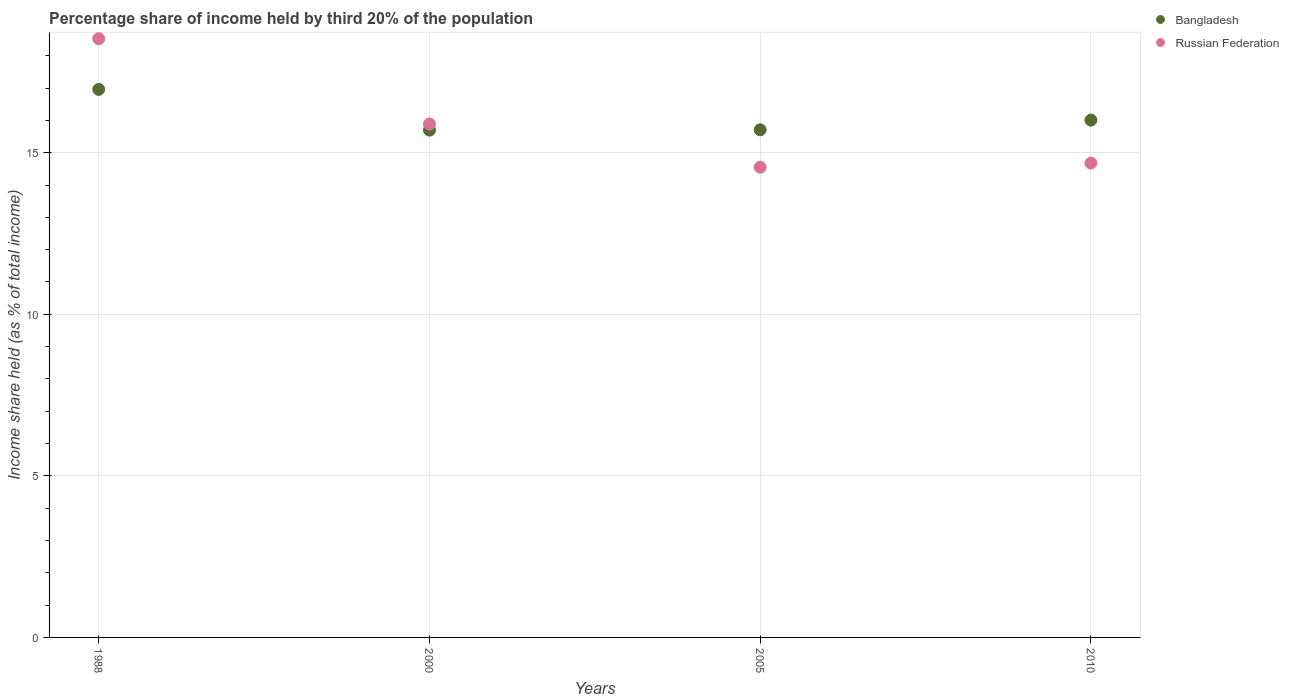What is the share of income held by third 20% of the population in Bangladesh in 2000?
Your answer should be compact. 15.7. Across all years, what is the maximum share of income held by third 20% of the population in Russian Federation?
Your answer should be compact. 18.53. In which year was the share of income held by third 20% of the population in Russian Federation maximum?
Your response must be concise. 1988. In which year was the share of income held by third 20% of the population in Russian Federation minimum?
Offer a terse response. 2005. What is the total share of income held by third 20% of the population in Bangladesh in the graph?
Offer a terse response. 64.38. What is the difference between the share of income held by third 20% of the population in Bangladesh in 2000 and that in 2005?
Offer a very short reply. -0.01. What is the difference between the share of income held by third 20% of the population in Bangladesh in 1988 and the share of income held by third 20% of the population in Russian Federation in 2005?
Provide a succinct answer. 2.41. What is the average share of income held by third 20% of the population in Bangladesh per year?
Offer a terse response. 16.09. In the year 1988, what is the difference between the share of income held by third 20% of the population in Bangladesh and share of income held by third 20% of the population in Russian Federation?
Offer a very short reply. -1.57. In how many years, is the share of income held by third 20% of the population in Russian Federation greater than 16 %?
Provide a short and direct response. 1. What is the ratio of the share of income held by third 20% of the population in Bangladesh in 2000 to that in 2005?
Provide a succinct answer. 1. What is the difference between the highest and the second highest share of income held by third 20% of the population in Russian Federation?
Your response must be concise. 2.64. What is the difference between the highest and the lowest share of income held by third 20% of the population in Russian Federation?
Your answer should be very brief. 3.98. Is the sum of the share of income held by third 20% of the population in Russian Federation in 1988 and 2005 greater than the maximum share of income held by third 20% of the population in Bangladesh across all years?
Your answer should be very brief. Yes. Does the share of income held by third 20% of the population in Russian Federation monotonically increase over the years?
Ensure brevity in your answer.  No. Is the share of income held by third 20% of the population in Russian Federation strictly greater than the share of income held by third 20% of the population in Bangladesh over the years?
Offer a terse response. No. How many dotlines are there?
Give a very brief answer. 2. How many years are there in the graph?
Give a very brief answer. 4. Are the values on the major ticks of Y-axis written in scientific E-notation?
Keep it short and to the point. No. Does the graph contain grids?
Your response must be concise. Yes. Where does the legend appear in the graph?
Offer a terse response. Top right. How are the legend labels stacked?
Give a very brief answer. Vertical. What is the title of the graph?
Offer a very short reply. Percentage share of income held by third 20% of the population. Does "Turks and Caicos Islands" appear as one of the legend labels in the graph?
Give a very brief answer. No. What is the label or title of the X-axis?
Give a very brief answer. Years. What is the label or title of the Y-axis?
Provide a short and direct response. Income share held (as % of total income). What is the Income share held (as % of total income) of Bangladesh in 1988?
Ensure brevity in your answer.  16.96. What is the Income share held (as % of total income) in Russian Federation in 1988?
Your answer should be compact. 18.53. What is the Income share held (as % of total income) of Bangladesh in 2000?
Make the answer very short. 15.7. What is the Income share held (as % of total income) in Russian Federation in 2000?
Give a very brief answer. 15.89. What is the Income share held (as % of total income) of Bangladesh in 2005?
Make the answer very short. 15.71. What is the Income share held (as % of total income) of Russian Federation in 2005?
Offer a very short reply. 14.55. What is the Income share held (as % of total income) of Bangladesh in 2010?
Provide a succinct answer. 16.01. What is the Income share held (as % of total income) in Russian Federation in 2010?
Keep it short and to the point. 14.68. Across all years, what is the maximum Income share held (as % of total income) in Bangladesh?
Offer a very short reply. 16.96. Across all years, what is the maximum Income share held (as % of total income) in Russian Federation?
Your answer should be compact. 18.53. Across all years, what is the minimum Income share held (as % of total income) of Bangladesh?
Ensure brevity in your answer.  15.7. Across all years, what is the minimum Income share held (as % of total income) in Russian Federation?
Keep it short and to the point. 14.55. What is the total Income share held (as % of total income) in Bangladesh in the graph?
Your answer should be compact. 64.38. What is the total Income share held (as % of total income) in Russian Federation in the graph?
Offer a very short reply. 63.65. What is the difference between the Income share held (as % of total income) of Bangladesh in 1988 and that in 2000?
Provide a short and direct response. 1.26. What is the difference between the Income share held (as % of total income) in Russian Federation in 1988 and that in 2000?
Your answer should be very brief. 2.64. What is the difference between the Income share held (as % of total income) in Bangladesh in 1988 and that in 2005?
Offer a terse response. 1.25. What is the difference between the Income share held (as % of total income) of Russian Federation in 1988 and that in 2005?
Provide a short and direct response. 3.98. What is the difference between the Income share held (as % of total income) in Bangladesh in 1988 and that in 2010?
Offer a very short reply. 0.95. What is the difference between the Income share held (as % of total income) in Russian Federation in 1988 and that in 2010?
Offer a terse response. 3.85. What is the difference between the Income share held (as % of total income) of Bangladesh in 2000 and that in 2005?
Offer a terse response. -0.01. What is the difference between the Income share held (as % of total income) in Russian Federation in 2000 and that in 2005?
Your response must be concise. 1.34. What is the difference between the Income share held (as % of total income) in Bangladesh in 2000 and that in 2010?
Offer a terse response. -0.31. What is the difference between the Income share held (as % of total income) in Russian Federation in 2000 and that in 2010?
Your response must be concise. 1.21. What is the difference between the Income share held (as % of total income) of Bangladesh in 2005 and that in 2010?
Ensure brevity in your answer.  -0.3. What is the difference between the Income share held (as % of total income) of Russian Federation in 2005 and that in 2010?
Offer a terse response. -0.13. What is the difference between the Income share held (as % of total income) in Bangladesh in 1988 and the Income share held (as % of total income) in Russian Federation in 2000?
Offer a terse response. 1.07. What is the difference between the Income share held (as % of total income) of Bangladesh in 1988 and the Income share held (as % of total income) of Russian Federation in 2005?
Offer a very short reply. 2.41. What is the difference between the Income share held (as % of total income) of Bangladesh in 1988 and the Income share held (as % of total income) of Russian Federation in 2010?
Offer a very short reply. 2.28. What is the difference between the Income share held (as % of total income) of Bangladesh in 2000 and the Income share held (as % of total income) of Russian Federation in 2005?
Offer a very short reply. 1.15. What is the difference between the Income share held (as % of total income) of Bangladesh in 2000 and the Income share held (as % of total income) of Russian Federation in 2010?
Your answer should be compact. 1.02. What is the difference between the Income share held (as % of total income) of Bangladesh in 2005 and the Income share held (as % of total income) of Russian Federation in 2010?
Ensure brevity in your answer.  1.03. What is the average Income share held (as % of total income) in Bangladesh per year?
Make the answer very short. 16.09. What is the average Income share held (as % of total income) in Russian Federation per year?
Offer a very short reply. 15.91. In the year 1988, what is the difference between the Income share held (as % of total income) of Bangladesh and Income share held (as % of total income) of Russian Federation?
Ensure brevity in your answer.  -1.57. In the year 2000, what is the difference between the Income share held (as % of total income) in Bangladesh and Income share held (as % of total income) in Russian Federation?
Make the answer very short. -0.19. In the year 2005, what is the difference between the Income share held (as % of total income) of Bangladesh and Income share held (as % of total income) of Russian Federation?
Provide a succinct answer. 1.16. In the year 2010, what is the difference between the Income share held (as % of total income) in Bangladesh and Income share held (as % of total income) in Russian Federation?
Provide a succinct answer. 1.33. What is the ratio of the Income share held (as % of total income) of Bangladesh in 1988 to that in 2000?
Make the answer very short. 1.08. What is the ratio of the Income share held (as % of total income) of Russian Federation in 1988 to that in 2000?
Offer a terse response. 1.17. What is the ratio of the Income share held (as % of total income) of Bangladesh in 1988 to that in 2005?
Your answer should be compact. 1.08. What is the ratio of the Income share held (as % of total income) in Russian Federation in 1988 to that in 2005?
Ensure brevity in your answer.  1.27. What is the ratio of the Income share held (as % of total income) of Bangladesh in 1988 to that in 2010?
Your answer should be very brief. 1.06. What is the ratio of the Income share held (as % of total income) in Russian Federation in 1988 to that in 2010?
Your answer should be very brief. 1.26. What is the ratio of the Income share held (as % of total income) of Russian Federation in 2000 to that in 2005?
Make the answer very short. 1.09. What is the ratio of the Income share held (as % of total income) of Bangladesh in 2000 to that in 2010?
Your answer should be very brief. 0.98. What is the ratio of the Income share held (as % of total income) in Russian Federation in 2000 to that in 2010?
Provide a short and direct response. 1.08. What is the ratio of the Income share held (as % of total income) of Bangladesh in 2005 to that in 2010?
Ensure brevity in your answer.  0.98. What is the difference between the highest and the second highest Income share held (as % of total income) of Russian Federation?
Provide a succinct answer. 2.64. What is the difference between the highest and the lowest Income share held (as % of total income) of Bangladesh?
Your response must be concise. 1.26. What is the difference between the highest and the lowest Income share held (as % of total income) of Russian Federation?
Ensure brevity in your answer.  3.98. 